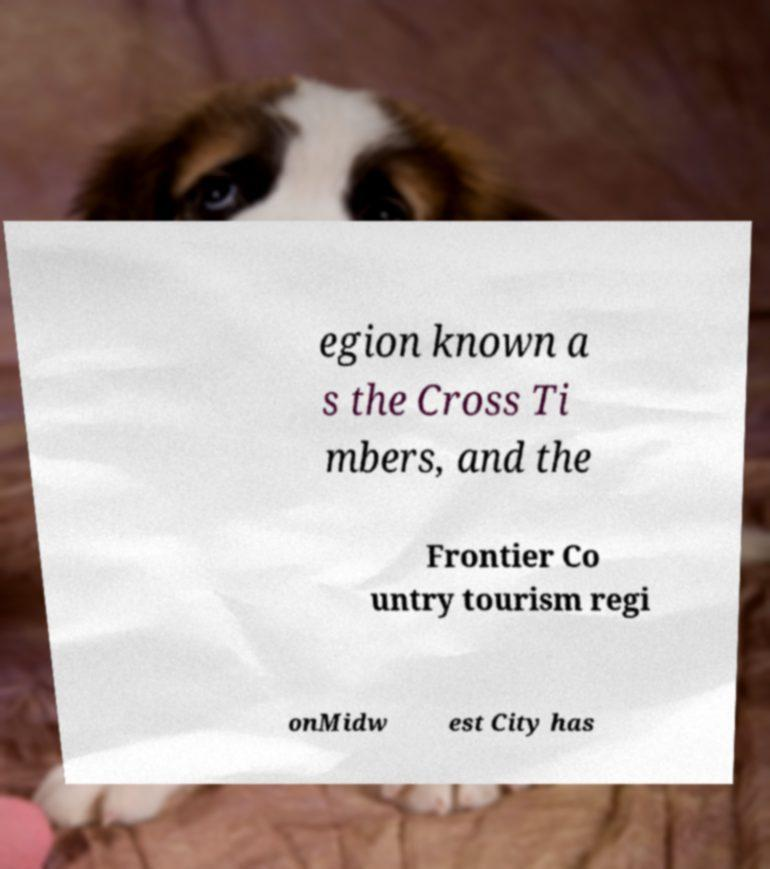I need the written content from this picture converted into text. Can you do that? egion known a s the Cross Ti mbers, and the Frontier Co untry tourism regi onMidw est City has 